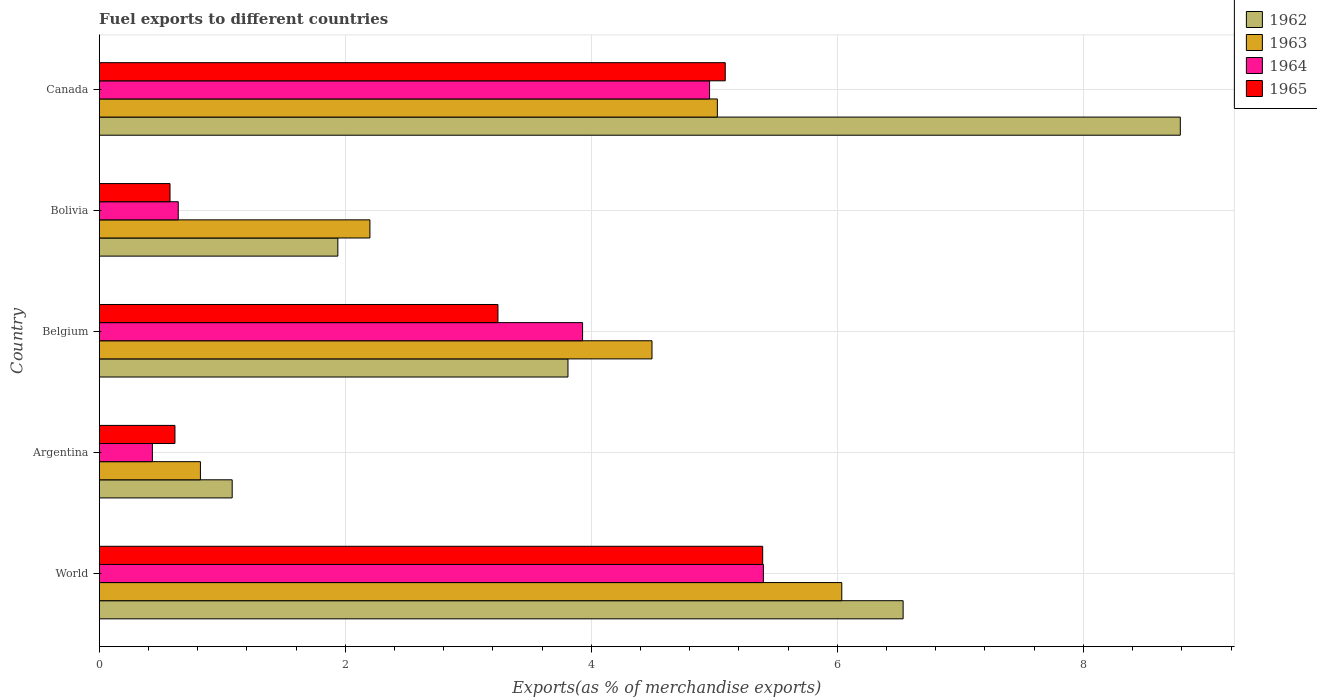How many different coloured bars are there?
Ensure brevity in your answer.  4. How many groups of bars are there?
Keep it short and to the point. 5. How many bars are there on the 5th tick from the top?
Your answer should be very brief. 4. What is the percentage of exports to different countries in 1964 in Canada?
Your answer should be compact. 4.96. Across all countries, what is the maximum percentage of exports to different countries in 1964?
Your response must be concise. 5.4. Across all countries, what is the minimum percentage of exports to different countries in 1965?
Provide a short and direct response. 0.58. What is the total percentage of exports to different countries in 1963 in the graph?
Your answer should be very brief. 18.58. What is the difference between the percentage of exports to different countries in 1965 in Bolivia and that in World?
Offer a terse response. -4.82. What is the difference between the percentage of exports to different countries in 1963 in Bolivia and the percentage of exports to different countries in 1964 in Canada?
Your answer should be very brief. -2.76. What is the average percentage of exports to different countries in 1965 per country?
Your answer should be compact. 2.98. What is the difference between the percentage of exports to different countries in 1964 and percentage of exports to different countries in 1962 in Bolivia?
Your answer should be very brief. -1.3. In how many countries, is the percentage of exports to different countries in 1964 greater than 0.4 %?
Keep it short and to the point. 5. What is the ratio of the percentage of exports to different countries in 1963 in Argentina to that in World?
Provide a succinct answer. 0.14. What is the difference between the highest and the second highest percentage of exports to different countries in 1963?
Provide a succinct answer. 1.01. What is the difference between the highest and the lowest percentage of exports to different countries in 1963?
Offer a terse response. 5.21. Is the sum of the percentage of exports to different countries in 1964 in Belgium and World greater than the maximum percentage of exports to different countries in 1962 across all countries?
Provide a short and direct response. Yes. Is it the case that in every country, the sum of the percentage of exports to different countries in 1965 and percentage of exports to different countries in 1962 is greater than the sum of percentage of exports to different countries in 1963 and percentage of exports to different countries in 1964?
Give a very brief answer. No. What does the 4th bar from the top in Belgium represents?
Your answer should be compact. 1962. How many bars are there?
Give a very brief answer. 20. How many countries are there in the graph?
Offer a terse response. 5. Where does the legend appear in the graph?
Your response must be concise. Top right. How many legend labels are there?
Offer a terse response. 4. How are the legend labels stacked?
Your answer should be compact. Vertical. What is the title of the graph?
Keep it short and to the point. Fuel exports to different countries. Does "1983" appear as one of the legend labels in the graph?
Your answer should be very brief. No. What is the label or title of the X-axis?
Keep it short and to the point. Exports(as % of merchandise exports). What is the Exports(as % of merchandise exports) of 1962 in World?
Offer a terse response. 6.53. What is the Exports(as % of merchandise exports) of 1963 in World?
Keep it short and to the point. 6.04. What is the Exports(as % of merchandise exports) of 1964 in World?
Offer a terse response. 5.4. What is the Exports(as % of merchandise exports) in 1965 in World?
Provide a succinct answer. 5.39. What is the Exports(as % of merchandise exports) in 1962 in Argentina?
Offer a terse response. 1.08. What is the Exports(as % of merchandise exports) in 1963 in Argentina?
Give a very brief answer. 0.82. What is the Exports(as % of merchandise exports) of 1964 in Argentina?
Offer a very short reply. 0.43. What is the Exports(as % of merchandise exports) of 1965 in Argentina?
Provide a short and direct response. 0.62. What is the Exports(as % of merchandise exports) of 1962 in Belgium?
Ensure brevity in your answer.  3.81. What is the Exports(as % of merchandise exports) of 1963 in Belgium?
Ensure brevity in your answer.  4.49. What is the Exports(as % of merchandise exports) of 1964 in Belgium?
Offer a terse response. 3.93. What is the Exports(as % of merchandise exports) of 1965 in Belgium?
Offer a terse response. 3.24. What is the Exports(as % of merchandise exports) of 1962 in Bolivia?
Your answer should be very brief. 1.94. What is the Exports(as % of merchandise exports) in 1963 in Bolivia?
Provide a succinct answer. 2.2. What is the Exports(as % of merchandise exports) of 1964 in Bolivia?
Give a very brief answer. 0.64. What is the Exports(as % of merchandise exports) in 1965 in Bolivia?
Provide a short and direct response. 0.58. What is the Exports(as % of merchandise exports) in 1962 in Canada?
Offer a very short reply. 8.79. What is the Exports(as % of merchandise exports) of 1963 in Canada?
Ensure brevity in your answer.  5.02. What is the Exports(as % of merchandise exports) of 1964 in Canada?
Your response must be concise. 4.96. What is the Exports(as % of merchandise exports) of 1965 in Canada?
Give a very brief answer. 5.09. Across all countries, what is the maximum Exports(as % of merchandise exports) of 1962?
Your response must be concise. 8.79. Across all countries, what is the maximum Exports(as % of merchandise exports) in 1963?
Your response must be concise. 6.04. Across all countries, what is the maximum Exports(as % of merchandise exports) of 1964?
Keep it short and to the point. 5.4. Across all countries, what is the maximum Exports(as % of merchandise exports) in 1965?
Provide a succinct answer. 5.39. Across all countries, what is the minimum Exports(as % of merchandise exports) in 1962?
Ensure brevity in your answer.  1.08. Across all countries, what is the minimum Exports(as % of merchandise exports) of 1963?
Ensure brevity in your answer.  0.82. Across all countries, what is the minimum Exports(as % of merchandise exports) of 1964?
Provide a succinct answer. 0.43. Across all countries, what is the minimum Exports(as % of merchandise exports) of 1965?
Ensure brevity in your answer.  0.58. What is the total Exports(as % of merchandise exports) of 1962 in the graph?
Your answer should be compact. 22.15. What is the total Exports(as % of merchandise exports) in 1963 in the graph?
Provide a short and direct response. 18.58. What is the total Exports(as % of merchandise exports) in 1964 in the graph?
Make the answer very short. 15.36. What is the total Exports(as % of merchandise exports) in 1965 in the graph?
Offer a terse response. 14.91. What is the difference between the Exports(as % of merchandise exports) in 1962 in World and that in Argentina?
Keep it short and to the point. 5.45. What is the difference between the Exports(as % of merchandise exports) of 1963 in World and that in Argentina?
Ensure brevity in your answer.  5.21. What is the difference between the Exports(as % of merchandise exports) in 1964 in World and that in Argentina?
Your answer should be compact. 4.97. What is the difference between the Exports(as % of merchandise exports) in 1965 in World and that in Argentina?
Your answer should be very brief. 4.78. What is the difference between the Exports(as % of merchandise exports) of 1962 in World and that in Belgium?
Ensure brevity in your answer.  2.72. What is the difference between the Exports(as % of merchandise exports) of 1963 in World and that in Belgium?
Your answer should be very brief. 1.54. What is the difference between the Exports(as % of merchandise exports) in 1964 in World and that in Belgium?
Provide a short and direct response. 1.47. What is the difference between the Exports(as % of merchandise exports) of 1965 in World and that in Belgium?
Make the answer very short. 2.15. What is the difference between the Exports(as % of merchandise exports) in 1962 in World and that in Bolivia?
Your response must be concise. 4.59. What is the difference between the Exports(as % of merchandise exports) in 1963 in World and that in Bolivia?
Give a very brief answer. 3.84. What is the difference between the Exports(as % of merchandise exports) of 1964 in World and that in Bolivia?
Your answer should be compact. 4.76. What is the difference between the Exports(as % of merchandise exports) of 1965 in World and that in Bolivia?
Ensure brevity in your answer.  4.82. What is the difference between the Exports(as % of merchandise exports) of 1962 in World and that in Canada?
Provide a short and direct response. -2.25. What is the difference between the Exports(as % of merchandise exports) of 1963 in World and that in Canada?
Your answer should be compact. 1.01. What is the difference between the Exports(as % of merchandise exports) in 1964 in World and that in Canada?
Provide a short and direct response. 0.44. What is the difference between the Exports(as % of merchandise exports) of 1965 in World and that in Canada?
Offer a very short reply. 0.3. What is the difference between the Exports(as % of merchandise exports) of 1962 in Argentina and that in Belgium?
Make the answer very short. -2.73. What is the difference between the Exports(as % of merchandise exports) of 1963 in Argentina and that in Belgium?
Keep it short and to the point. -3.67. What is the difference between the Exports(as % of merchandise exports) in 1964 in Argentina and that in Belgium?
Your answer should be compact. -3.5. What is the difference between the Exports(as % of merchandise exports) in 1965 in Argentina and that in Belgium?
Provide a succinct answer. -2.63. What is the difference between the Exports(as % of merchandise exports) of 1962 in Argentina and that in Bolivia?
Your answer should be very brief. -0.86. What is the difference between the Exports(as % of merchandise exports) in 1963 in Argentina and that in Bolivia?
Give a very brief answer. -1.38. What is the difference between the Exports(as % of merchandise exports) of 1964 in Argentina and that in Bolivia?
Provide a short and direct response. -0.21. What is the difference between the Exports(as % of merchandise exports) in 1965 in Argentina and that in Bolivia?
Make the answer very short. 0.04. What is the difference between the Exports(as % of merchandise exports) of 1962 in Argentina and that in Canada?
Provide a succinct answer. -7.71. What is the difference between the Exports(as % of merchandise exports) of 1963 in Argentina and that in Canada?
Keep it short and to the point. -4.2. What is the difference between the Exports(as % of merchandise exports) in 1964 in Argentina and that in Canada?
Ensure brevity in your answer.  -4.53. What is the difference between the Exports(as % of merchandise exports) in 1965 in Argentina and that in Canada?
Your answer should be very brief. -4.47. What is the difference between the Exports(as % of merchandise exports) of 1962 in Belgium and that in Bolivia?
Your answer should be compact. 1.87. What is the difference between the Exports(as % of merchandise exports) in 1963 in Belgium and that in Bolivia?
Provide a short and direct response. 2.29. What is the difference between the Exports(as % of merchandise exports) of 1964 in Belgium and that in Bolivia?
Your answer should be compact. 3.29. What is the difference between the Exports(as % of merchandise exports) of 1965 in Belgium and that in Bolivia?
Keep it short and to the point. 2.67. What is the difference between the Exports(as % of merchandise exports) in 1962 in Belgium and that in Canada?
Keep it short and to the point. -4.98. What is the difference between the Exports(as % of merchandise exports) of 1963 in Belgium and that in Canada?
Your response must be concise. -0.53. What is the difference between the Exports(as % of merchandise exports) of 1964 in Belgium and that in Canada?
Keep it short and to the point. -1.03. What is the difference between the Exports(as % of merchandise exports) of 1965 in Belgium and that in Canada?
Keep it short and to the point. -1.85. What is the difference between the Exports(as % of merchandise exports) of 1962 in Bolivia and that in Canada?
Keep it short and to the point. -6.85. What is the difference between the Exports(as % of merchandise exports) of 1963 in Bolivia and that in Canada?
Make the answer very short. -2.82. What is the difference between the Exports(as % of merchandise exports) of 1964 in Bolivia and that in Canada?
Your answer should be compact. -4.32. What is the difference between the Exports(as % of merchandise exports) in 1965 in Bolivia and that in Canada?
Provide a short and direct response. -4.51. What is the difference between the Exports(as % of merchandise exports) in 1962 in World and the Exports(as % of merchandise exports) in 1963 in Argentina?
Give a very brief answer. 5.71. What is the difference between the Exports(as % of merchandise exports) of 1962 in World and the Exports(as % of merchandise exports) of 1964 in Argentina?
Your answer should be very brief. 6.1. What is the difference between the Exports(as % of merchandise exports) in 1962 in World and the Exports(as % of merchandise exports) in 1965 in Argentina?
Give a very brief answer. 5.92. What is the difference between the Exports(as % of merchandise exports) in 1963 in World and the Exports(as % of merchandise exports) in 1964 in Argentina?
Offer a very short reply. 5.6. What is the difference between the Exports(as % of merchandise exports) of 1963 in World and the Exports(as % of merchandise exports) of 1965 in Argentina?
Your response must be concise. 5.42. What is the difference between the Exports(as % of merchandise exports) of 1964 in World and the Exports(as % of merchandise exports) of 1965 in Argentina?
Your answer should be compact. 4.78. What is the difference between the Exports(as % of merchandise exports) in 1962 in World and the Exports(as % of merchandise exports) in 1963 in Belgium?
Provide a short and direct response. 2.04. What is the difference between the Exports(as % of merchandise exports) in 1962 in World and the Exports(as % of merchandise exports) in 1964 in Belgium?
Offer a terse response. 2.61. What is the difference between the Exports(as % of merchandise exports) of 1962 in World and the Exports(as % of merchandise exports) of 1965 in Belgium?
Ensure brevity in your answer.  3.29. What is the difference between the Exports(as % of merchandise exports) of 1963 in World and the Exports(as % of merchandise exports) of 1964 in Belgium?
Provide a short and direct response. 2.11. What is the difference between the Exports(as % of merchandise exports) of 1963 in World and the Exports(as % of merchandise exports) of 1965 in Belgium?
Make the answer very short. 2.79. What is the difference between the Exports(as % of merchandise exports) of 1964 in World and the Exports(as % of merchandise exports) of 1965 in Belgium?
Offer a very short reply. 2.16. What is the difference between the Exports(as % of merchandise exports) in 1962 in World and the Exports(as % of merchandise exports) in 1963 in Bolivia?
Give a very brief answer. 4.33. What is the difference between the Exports(as % of merchandise exports) in 1962 in World and the Exports(as % of merchandise exports) in 1964 in Bolivia?
Offer a very short reply. 5.89. What is the difference between the Exports(as % of merchandise exports) of 1962 in World and the Exports(as % of merchandise exports) of 1965 in Bolivia?
Ensure brevity in your answer.  5.96. What is the difference between the Exports(as % of merchandise exports) of 1963 in World and the Exports(as % of merchandise exports) of 1964 in Bolivia?
Your answer should be very brief. 5.39. What is the difference between the Exports(as % of merchandise exports) of 1963 in World and the Exports(as % of merchandise exports) of 1965 in Bolivia?
Offer a terse response. 5.46. What is the difference between the Exports(as % of merchandise exports) of 1964 in World and the Exports(as % of merchandise exports) of 1965 in Bolivia?
Ensure brevity in your answer.  4.82. What is the difference between the Exports(as % of merchandise exports) of 1962 in World and the Exports(as % of merchandise exports) of 1963 in Canada?
Provide a short and direct response. 1.51. What is the difference between the Exports(as % of merchandise exports) in 1962 in World and the Exports(as % of merchandise exports) in 1964 in Canada?
Make the answer very short. 1.57. What is the difference between the Exports(as % of merchandise exports) of 1962 in World and the Exports(as % of merchandise exports) of 1965 in Canada?
Provide a succinct answer. 1.45. What is the difference between the Exports(as % of merchandise exports) of 1963 in World and the Exports(as % of merchandise exports) of 1964 in Canada?
Ensure brevity in your answer.  1.07. What is the difference between the Exports(as % of merchandise exports) in 1963 in World and the Exports(as % of merchandise exports) in 1965 in Canada?
Give a very brief answer. 0.95. What is the difference between the Exports(as % of merchandise exports) of 1964 in World and the Exports(as % of merchandise exports) of 1965 in Canada?
Provide a short and direct response. 0.31. What is the difference between the Exports(as % of merchandise exports) of 1962 in Argentina and the Exports(as % of merchandise exports) of 1963 in Belgium?
Make the answer very short. -3.41. What is the difference between the Exports(as % of merchandise exports) of 1962 in Argentina and the Exports(as % of merchandise exports) of 1964 in Belgium?
Give a very brief answer. -2.85. What is the difference between the Exports(as % of merchandise exports) of 1962 in Argentina and the Exports(as % of merchandise exports) of 1965 in Belgium?
Your response must be concise. -2.16. What is the difference between the Exports(as % of merchandise exports) in 1963 in Argentina and the Exports(as % of merchandise exports) in 1964 in Belgium?
Your response must be concise. -3.11. What is the difference between the Exports(as % of merchandise exports) of 1963 in Argentina and the Exports(as % of merchandise exports) of 1965 in Belgium?
Offer a terse response. -2.42. What is the difference between the Exports(as % of merchandise exports) in 1964 in Argentina and the Exports(as % of merchandise exports) in 1965 in Belgium?
Keep it short and to the point. -2.81. What is the difference between the Exports(as % of merchandise exports) in 1962 in Argentina and the Exports(as % of merchandise exports) in 1963 in Bolivia?
Provide a short and direct response. -1.12. What is the difference between the Exports(as % of merchandise exports) of 1962 in Argentina and the Exports(as % of merchandise exports) of 1964 in Bolivia?
Your answer should be compact. 0.44. What is the difference between the Exports(as % of merchandise exports) of 1962 in Argentina and the Exports(as % of merchandise exports) of 1965 in Bolivia?
Give a very brief answer. 0.51. What is the difference between the Exports(as % of merchandise exports) of 1963 in Argentina and the Exports(as % of merchandise exports) of 1964 in Bolivia?
Offer a terse response. 0.18. What is the difference between the Exports(as % of merchandise exports) in 1963 in Argentina and the Exports(as % of merchandise exports) in 1965 in Bolivia?
Offer a terse response. 0.25. What is the difference between the Exports(as % of merchandise exports) in 1964 in Argentina and the Exports(as % of merchandise exports) in 1965 in Bolivia?
Offer a terse response. -0.14. What is the difference between the Exports(as % of merchandise exports) in 1962 in Argentina and the Exports(as % of merchandise exports) in 1963 in Canada?
Your answer should be very brief. -3.94. What is the difference between the Exports(as % of merchandise exports) of 1962 in Argentina and the Exports(as % of merchandise exports) of 1964 in Canada?
Provide a short and direct response. -3.88. What is the difference between the Exports(as % of merchandise exports) in 1962 in Argentina and the Exports(as % of merchandise exports) in 1965 in Canada?
Give a very brief answer. -4.01. What is the difference between the Exports(as % of merchandise exports) of 1963 in Argentina and the Exports(as % of merchandise exports) of 1964 in Canada?
Keep it short and to the point. -4.14. What is the difference between the Exports(as % of merchandise exports) of 1963 in Argentina and the Exports(as % of merchandise exports) of 1965 in Canada?
Offer a terse response. -4.27. What is the difference between the Exports(as % of merchandise exports) in 1964 in Argentina and the Exports(as % of merchandise exports) in 1965 in Canada?
Offer a very short reply. -4.66. What is the difference between the Exports(as % of merchandise exports) in 1962 in Belgium and the Exports(as % of merchandise exports) in 1963 in Bolivia?
Give a very brief answer. 1.61. What is the difference between the Exports(as % of merchandise exports) in 1962 in Belgium and the Exports(as % of merchandise exports) in 1964 in Bolivia?
Your answer should be compact. 3.17. What is the difference between the Exports(as % of merchandise exports) of 1962 in Belgium and the Exports(as % of merchandise exports) of 1965 in Bolivia?
Make the answer very short. 3.23. What is the difference between the Exports(as % of merchandise exports) of 1963 in Belgium and the Exports(as % of merchandise exports) of 1964 in Bolivia?
Offer a terse response. 3.85. What is the difference between the Exports(as % of merchandise exports) of 1963 in Belgium and the Exports(as % of merchandise exports) of 1965 in Bolivia?
Keep it short and to the point. 3.92. What is the difference between the Exports(as % of merchandise exports) in 1964 in Belgium and the Exports(as % of merchandise exports) in 1965 in Bolivia?
Give a very brief answer. 3.35. What is the difference between the Exports(as % of merchandise exports) in 1962 in Belgium and the Exports(as % of merchandise exports) in 1963 in Canada?
Make the answer very short. -1.21. What is the difference between the Exports(as % of merchandise exports) of 1962 in Belgium and the Exports(as % of merchandise exports) of 1964 in Canada?
Give a very brief answer. -1.15. What is the difference between the Exports(as % of merchandise exports) in 1962 in Belgium and the Exports(as % of merchandise exports) in 1965 in Canada?
Your answer should be compact. -1.28. What is the difference between the Exports(as % of merchandise exports) of 1963 in Belgium and the Exports(as % of merchandise exports) of 1964 in Canada?
Your answer should be very brief. -0.47. What is the difference between the Exports(as % of merchandise exports) of 1963 in Belgium and the Exports(as % of merchandise exports) of 1965 in Canada?
Your answer should be compact. -0.6. What is the difference between the Exports(as % of merchandise exports) in 1964 in Belgium and the Exports(as % of merchandise exports) in 1965 in Canada?
Your answer should be very brief. -1.16. What is the difference between the Exports(as % of merchandise exports) in 1962 in Bolivia and the Exports(as % of merchandise exports) in 1963 in Canada?
Your answer should be very brief. -3.08. What is the difference between the Exports(as % of merchandise exports) of 1962 in Bolivia and the Exports(as % of merchandise exports) of 1964 in Canada?
Your answer should be compact. -3.02. What is the difference between the Exports(as % of merchandise exports) of 1962 in Bolivia and the Exports(as % of merchandise exports) of 1965 in Canada?
Provide a succinct answer. -3.15. What is the difference between the Exports(as % of merchandise exports) of 1963 in Bolivia and the Exports(as % of merchandise exports) of 1964 in Canada?
Offer a very short reply. -2.76. What is the difference between the Exports(as % of merchandise exports) of 1963 in Bolivia and the Exports(as % of merchandise exports) of 1965 in Canada?
Your response must be concise. -2.89. What is the difference between the Exports(as % of merchandise exports) in 1964 in Bolivia and the Exports(as % of merchandise exports) in 1965 in Canada?
Provide a succinct answer. -4.45. What is the average Exports(as % of merchandise exports) of 1962 per country?
Keep it short and to the point. 4.43. What is the average Exports(as % of merchandise exports) of 1963 per country?
Provide a succinct answer. 3.72. What is the average Exports(as % of merchandise exports) of 1964 per country?
Provide a succinct answer. 3.07. What is the average Exports(as % of merchandise exports) in 1965 per country?
Give a very brief answer. 2.98. What is the difference between the Exports(as % of merchandise exports) in 1962 and Exports(as % of merchandise exports) in 1963 in World?
Keep it short and to the point. 0.5. What is the difference between the Exports(as % of merchandise exports) in 1962 and Exports(as % of merchandise exports) in 1964 in World?
Your answer should be very brief. 1.14. What is the difference between the Exports(as % of merchandise exports) of 1962 and Exports(as % of merchandise exports) of 1965 in World?
Your answer should be compact. 1.14. What is the difference between the Exports(as % of merchandise exports) in 1963 and Exports(as % of merchandise exports) in 1964 in World?
Your response must be concise. 0.64. What is the difference between the Exports(as % of merchandise exports) of 1963 and Exports(as % of merchandise exports) of 1965 in World?
Give a very brief answer. 0.64. What is the difference between the Exports(as % of merchandise exports) of 1964 and Exports(as % of merchandise exports) of 1965 in World?
Offer a terse response. 0.01. What is the difference between the Exports(as % of merchandise exports) in 1962 and Exports(as % of merchandise exports) in 1963 in Argentina?
Your response must be concise. 0.26. What is the difference between the Exports(as % of merchandise exports) of 1962 and Exports(as % of merchandise exports) of 1964 in Argentina?
Provide a short and direct response. 0.65. What is the difference between the Exports(as % of merchandise exports) in 1962 and Exports(as % of merchandise exports) in 1965 in Argentina?
Your answer should be compact. 0.47. What is the difference between the Exports(as % of merchandise exports) of 1963 and Exports(as % of merchandise exports) of 1964 in Argentina?
Keep it short and to the point. 0.39. What is the difference between the Exports(as % of merchandise exports) of 1963 and Exports(as % of merchandise exports) of 1965 in Argentina?
Your response must be concise. 0.21. What is the difference between the Exports(as % of merchandise exports) in 1964 and Exports(as % of merchandise exports) in 1965 in Argentina?
Make the answer very short. -0.18. What is the difference between the Exports(as % of merchandise exports) of 1962 and Exports(as % of merchandise exports) of 1963 in Belgium?
Make the answer very short. -0.68. What is the difference between the Exports(as % of merchandise exports) of 1962 and Exports(as % of merchandise exports) of 1964 in Belgium?
Your answer should be very brief. -0.12. What is the difference between the Exports(as % of merchandise exports) of 1962 and Exports(as % of merchandise exports) of 1965 in Belgium?
Offer a terse response. 0.57. What is the difference between the Exports(as % of merchandise exports) of 1963 and Exports(as % of merchandise exports) of 1964 in Belgium?
Keep it short and to the point. 0.56. What is the difference between the Exports(as % of merchandise exports) in 1963 and Exports(as % of merchandise exports) in 1965 in Belgium?
Your response must be concise. 1.25. What is the difference between the Exports(as % of merchandise exports) in 1964 and Exports(as % of merchandise exports) in 1965 in Belgium?
Your answer should be very brief. 0.69. What is the difference between the Exports(as % of merchandise exports) of 1962 and Exports(as % of merchandise exports) of 1963 in Bolivia?
Provide a short and direct response. -0.26. What is the difference between the Exports(as % of merchandise exports) of 1962 and Exports(as % of merchandise exports) of 1964 in Bolivia?
Ensure brevity in your answer.  1.3. What is the difference between the Exports(as % of merchandise exports) in 1962 and Exports(as % of merchandise exports) in 1965 in Bolivia?
Keep it short and to the point. 1.36. What is the difference between the Exports(as % of merchandise exports) in 1963 and Exports(as % of merchandise exports) in 1964 in Bolivia?
Offer a terse response. 1.56. What is the difference between the Exports(as % of merchandise exports) in 1963 and Exports(as % of merchandise exports) in 1965 in Bolivia?
Give a very brief answer. 1.62. What is the difference between the Exports(as % of merchandise exports) of 1964 and Exports(as % of merchandise exports) of 1965 in Bolivia?
Give a very brief answer. 0.07. What is the difference between the Exports(as % of merchandise exports) in 1962 and Exports(as % of merchandise exports) in 1963 in Canada?
Provide a short and direct response. 3.76. What is the difference between the Exports(as % of merchandise exports) of 1962 and Exports(as % of merchandise exports) of 1964 in Canada?
Make the answer very short. 3.83. What is the difference between the Exports(as % of merchandise exports) in 1962 and Exports(as % of merchandise exports) in 1965 in Canada?
Provide a short and direct response. 3.7. What is the difference between the Exports(as % of merchandise exports) in 1963 and Exports(as % of merchandise exports) in 1964 in Canada?
Ensure brevity in your answer.  0.06. What is the difference between the Exports(as % of merchandise exports) in 1963 and Exports(as % of merchandise exports) in 1965 in Canada?
Offer a very short reply. -0.06. What is the difference between the Exports(as % of merchandise exports) in 1964 and Exports(as % of merchandise exports) in 1965 in Canada?
Give a very brief answer. -0.13. What is the ratio of the Exports(as % of merchandise exports) in 1962 in World to that in Argentina?
Offer a very short reply. 6.05. What is the ratio of the Exports(as % of merchandise exports) in 1963 in World to that in Argentina?
Your answer should be very brief. 7.34. What is the ratio of the Exports(as % of merchandise exports) in 1964 in World to that in Argentina?
Provide a short and direct response. 12.49. What is the ratio of the Exports(as % of merchandise exports) of 1965 in World to that in Argentina?
Make the answer very short. 8.76. What is the ratio of the Exports(as % of merchandise exports) of 1962 in World to that in Belgium?
Provide a short and direct response. 1.72. What is the ratio of the Exports(as % of merchandise exports) in 1963 in World to that in Belgium?
Your answer should be compact. 1.34. What is the ratio of the Exports(as % of merchandise exports) of 1964 in World to that in Belgium?
Make the answer very short. 1.37. What is the ratio of the Exports(as % of merchandise exports) in 1965 in World to that in Belgium?
Ensure brevity in your answer.  1.66. What is the ratio of the Exports(as % of merchandise exports) of 1962 in World to that in Bolivia?
Give a very brief answer. 3.37. What is the ratio of the Exports(as % of merchandise exports) in 1963 in World to that in Bolivia?
Provide a short and direct response. 2.74. What is the ratio of the Exports(as % of merchandise exports) in 1964 in World to that in Bolivia?
Give a very brief answer. 8.4. What is the ratio of the Exports(as % of merchandise exports) in 1965 in World to that in Bolivia?
Give a very brief answer. 9.37. What is the ratio of the Exports(as % of merchandise exports) of 1962 in World to that in Canada?
Give a very brief answer. 0.74. What is the ratio of the Exports(as % of merchandise exports) of 1963 in World to that in Canada?
Offer a very short reply. 1.2. What is the ratio of the Exports(as % of merchandise exports) of 1964 in World to that in Canada?
Provide a short and direct response. 1.09. What is the ratio of the Exports(as % of merchandise exports) in 1965 in World to that in Canada?
Offer a terse response. 1.06. What is the ratio of the Exports(as % of merchandise exports) of 1962 in Argentina to that in Belgium?
Give a very brief answer. 0.28. What is the ratio of the Exports(as % of merchandise exports) in 1963 in Argentina to that in Belgium?
Provide a succinct answer. 0.18. What is the ratio of the Exports(as % of merchandise exports) of 1964 in Argentina to that in Belgium?
Provide a succinct answer. 0.11. What is the ratio of the Exports(as % of merchandise exports) in 1965 in Argentina to that in Belgium?
Ensure brevity in your answer.  0.19. What is the ratio of the Exports(as % of merchandise exports) of 1962 in Argentina to that in Bolivia?
Provide a short and direct response. 0.56. What is the ratio of the Exports(as % of merchandise exports) of 1963 in Argentina to that in Bolivia?
Give a very brief answer. 0.37. What is the ratio of the Exports(as % of merchandise exports) of 1964 in Argentina to that in Bolivia?
Your answer should be very brief. 0.67. What is the ratio of the Exports(as % of merchandise exports) of 1965 in Argentina to that in Bolivia?
Provide a succinct answer. 1.07. What is the ratio of the Exports(as % of merchandise exports) in 1962 in Argentina to that in Canada?
Give a very brief answer. 0.12. What is the ratio of the Exports(as % of merchandise exports) in 1963 in Argentina to that in Canada?
Make the answer very short. 0.16. What is the ratio of the Exports(as % of merchandise exports) in 1964 in Argentina to that in Canada?
Keep it short and to the point. 0.09. What is the ratio of the Exports(as % of merchandise exports) in 1965 in Argentina to that in Canada?
Offer a very short reply. 0.12. What is the ratio of the Exports(as % of merchandise exports) in 1962 in Belgium to that in Bolivia?
Your answer should be very brief. 1.96. What is the ratio of the Exports(as % of merchandise exports) in 1963 in Belgium to that in Bolivia?
Your answer should be compact. 2.04. What is the ratio of the Exports(as % of merchandise exports) in 1964 in Belgium to that in Bolivia?
Make the answer very short. 6.12. What is the ratio of the Exports(as % of merchandise exports) of 1965 in Belgium to that in Bolivia?
Provide a succinct answer. 5.63. What is the ratio of the Exports(as % of merchandise exports) in 1962 in Belgium to that in Canada?
Ensure brevity in your answer.  0.43. What is the ratio of the Exports(as % of merchandise exports) of 1963 in Belgium to that in Canada?
Ensure brevity in your answer.  0.89. What is the ratio of the Exports(as % of merchandise exports) of 1964 in Belgium to that in Canada?
Your response must be concise. 0.79. What is the ratio of the Exports(as % of merchandise exports) of 1965 in Belgium to that in Canada?
Give a very brief answer. 0.64. What is the ratio of the Exports(as % of merchandise exports) of 1962 in Bolivia to that in Canada?
Provide a succinct answer. 0.22. What is the ratio of the Exports(as % of merchandise exports) in 1963 in Bolivia to that in Canada?
Keep it short and to the point. 0.44. What is the ratio of the Exports(as % of merchandise exports) in 1964 in Bolivia to that in Canada?
Provide a short and direct response. 0.13. What is the ratio of the Exports(as % of merchandise exports) of 1965 in Bolivia to that in Canada?
Your response must be concise. 0.11. What is the difference between the highest and the second highest Exports(as % of merchandise exports) in 1962?
Your response must be concise. 2.25. What is the difference between the highest and the second highest Exports(as % of merchandise exports) in 1963?
Ensure brevity in your answer.  1.01. What is the difference between the highest and the second highest Exports(as % of merchandise exports) in 1964?
Keep it short and to the point. 0.44. What is the difference between the highest and the second highest Exports(as % of merchandise exports) in 1965?
Provide a succinct answer. 0.3. What is the difference between the highest and the lowest Exports(as % of merchandise exports) in 1962?
Provide a succinct answer. 7.71. What is the difference between the highest and the lowest Exports(as % of merchandise exports) in 1963?
Your answer should be compact. 5.21. What is the difference between the highest and the lowest Exports(as % of merchandise exports) in 1964?
Provide a short and direct response. 4.97. What is the difference between the highest and the lowest Exports(as % of merchandise exports) in 1965?
Provide a short and direct response. 4.82. 